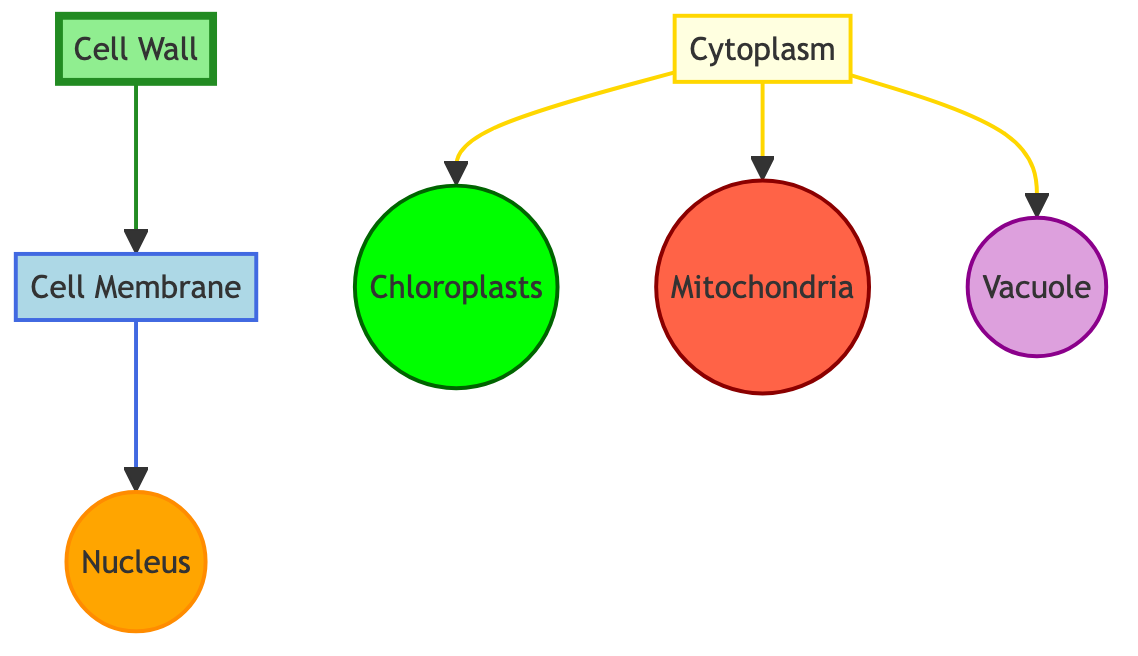What is the color of the cell wall? The diagram indicates that the cell wall is filled with a light green color (#90EE90). This can be verified by looking at the color coding defined in the diagram.
Answer: light green How many organelles are shown in the diagram? The diagram features five distinct organelles: nucleus, chloroplasts, mitochondria, and vacuole. Counting these, we see a total of four organelles plus the cell wall and cell membrane, which totals six structures.
Answer: six Which organelle is connected to the cytoplasm? The cytoplasm in the diagram connects to multiple organelles: chloroplasts, mitochondria, and vacuole. By tracing the links, we can confirm all three organelles are directly connected to the cytoplasm.
Answer: chloroplasts, mitochondria, vacuole What is the stroke color of the nucleus? The nucleus is outlined with a stroke color that is a shade of orange (#FF8C00). This can be deduced from the class definition in the diagram for the nucleus.
Answer: orange Which organelle is directly above the cell membrane? Following the downward direction from the cell membrane, it is clear that the nucleus is positioned directly below (or above) the cell membrane in the diagram.
Answer: nucleus Which two organelles are linked to the cytoplasm? The chloroplasts and mitochondria are both shown connecting to the cytoplasm in the diagram. By examining the direct connections from the cytoplasm node, we can see these links clearly represented.
Answer: chloroplasts, mitochondria What is the stroke width of the vacuole? The vacuole in the diagram has a defined stroke width of 2 pixels, as per its class definition, similar to other organelles like the nucleus and mitochondria.
Answer: 2 pixels Which organelle is associated with a green color scheme? The chloroplast is specifically assigned a bright green color (#00FF00) in the diagram. This distinctive color coding helps in identifying chloroplasts amongst other organelles.
Answer: bright green What is the relationship between the cell wall and cell membrane? The diagram shows a direct connection where the cell wall points to the cell membrane indicating a structural relationship in plant cells. This helps illustrate that the cell wall surrounds the cell membrane.
Answer: the cell wall surrounds the cell membrane 